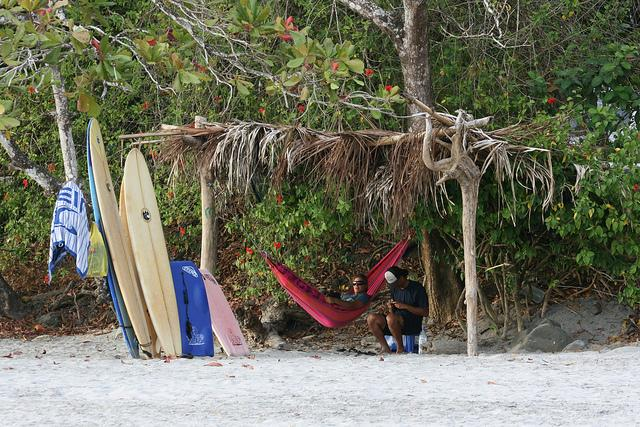What is the person sitting near? hammock 